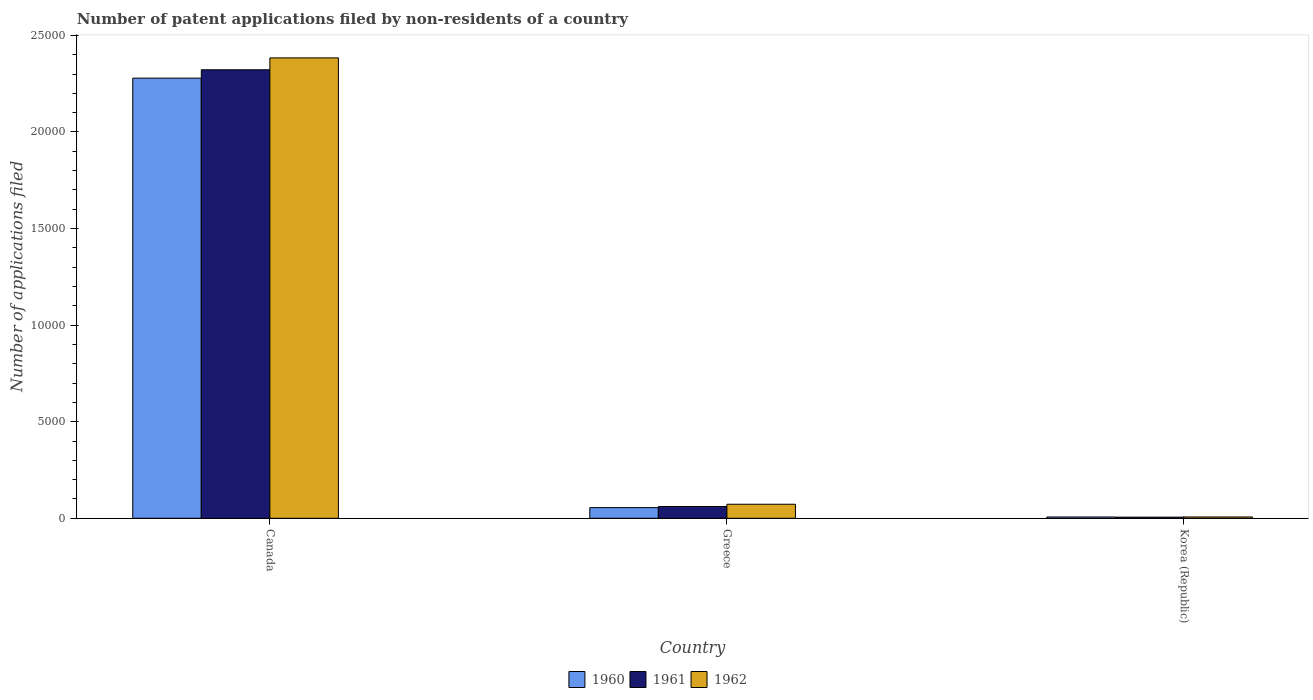How many different coloured bars are there?
Your response must be concise. 3. In how many cases, is the number of bars for a given country not equal to the number of legend labels?
Your answer should be very brief. 0. What is the number of applications filed in 1962 in Korea (Republic)?
Ensure brevity in your answer.  68. Across all countries, what is the maximum number of applications filed in 1960?
Offer a very short reply. 2.28e+04. In which country was the number of applications filed in 1960 minimum?
Your response must be concise. Korea (Republic). What is the total number of applications filed in 1960 in the graph?
Keep it short and to the point. 2.34e+04. What is the difference between the number of applications filed in 1961 in Canada and that in Greece?
Give a very brief answer. 2.26e+04. What is the difference between the number of applications filed in 1962 in Greece and the number of applications filed in 1961 in Canada?
Provide a short and direct response. -2.25e+04. What is the average number of applications filed in 1960 per country?
Give a very brief answer. 7801. What is the difference between the number of applications filed of/in 1962 and number of applications filed of/in 1961 in Greece?
Offer a terse response. 117. In how many countries, is the number of applications filed in 1960 greater than 16000?
Provide a short and direct response. 1. What is the ratio of the number of applications filed in 1960 in Canada to that in Greece?
Ensure brevity in your answer.  41.35. Is the number of applications filed in 1962 in Canada less than that in Greece?
Keep it short and to the point. No. What is the difference between the highest and the second highest number of applications filed in 1960?
Keep it short and to the point. 2.27e+04. What is the difference between the highest and the lowest number of applications filed in 1960?
Provide a succinct answer. 2.27e+04. In how many countries, is the number of applications filed in 1961 greater than the average number of applications filed in 1961 taken over all countries?
Keep it short and to the point. 1. What does the 2nd bar from the left in Canada represents?
Your response must be concise. 1961. Is it the case that in every country, the sum of the number of applications filed in 1962 and number of applications filed in 1960 is greater than the number of applications filed in 1961?
Provide a succinct answer. Yes. How many bars are there?
Provide a succinct answer. 9. Are all the bars in the graph horizontal?
Provide a short and direct response. No. How many countries are there in the graph?
Offer a very short reply. 3. What is the difference between two consecutive major ticks on the Y-axis?
Your answer should be very brief. 5000. Are the values on the major ticks of Y-axis written in scientific E-notation?
Your answer should be compact. No. Does the graph contain any zero values?
Provide a short and direct response. No. Where does the legend appear in the graph?
Your response must be concise. Bottom center. What is the title of the graph?
Provide a short and direct response. Number of patent applications filed by non-residents of a country. What is the label or title of the Y-axis?
Your response must be concise. Number of applications filed. What is the Number of applications filed of 1960 in Canada?
Provide a short and direct response. 2.28e+04. What is the Number of applications filed of 1961 in Canada?
Offer a very short reply. 2.32e+04. What is the Number of applications filed in 1962 in Canada?
Your answer should be compact. 2.38e+04. What is the Number of applications filed in 1960 in Greece?
Keep it short and to the point. 551. What is the Number of applications filed of 1961 in Greece?
Offer a very short reply. 609. What is the Number of applications filed in 1962 in Greece?
Your answer should be very brief. 726. What is the Number of applications filed of 1962 in Korea (Republic)?
Provide a short and direct response. 68. Across all countries, what is the maximum Number of applications filed in 1960?
Offer a terse response. 2.28e+04. Across all countries, what is the maximum Number of applications filed in 1961?
Give a very brief answer. 2.32e+04. Across all countries, what is the maximum Number of applications filed in 1962?
Provide a succinct answer. 2.38e+04. Across all countries, what is the minimum Number of applications filed in 1960?
Make the answer very short. 66. Across all countries, what is the minimum Number of applications filed in 1962?
Keep it short and to the point. 68. What is the total Number of applications filed in 1960 in the graph?
Provide a succinct answer. 2.34e+04. What is the total Number of applications filed of 1961 in the graph?
Give a very brief answer. 2.39e+04. What is the total Number of applications filed in 1962 in the graph?
Provide a succinct answer. 2.46e+04. What is the difference between the Number of applications filed in 1960 in Canada and that in Greece?
Make the answer very short. 2.22e+04. What is the difference between the Number of applications filed in 1961 in Canada and that in Greece?
Ensure brevity in your answer.  2.26e+04. What is the difference between the Number of applications filed in 1962 in Canada and that in Greece?
Provide a succinct answer. 2.31e+04. What is the difference between the Number of applications filed of 1960 in Canada and that in Korea (Republic)?
Provide a short and direct response. 2.27e+04. What is the difference between the Number of applications filed in 1961 in Canada and that in Korea (Republic)?
Provide a short and direct response. 2.32e+04. What is the difference between the Number of applications filed in 1962 in Canada and that in Korea (Republic)?
Make the answer very short. 2.38e+04. What is the difference between the Number of applications filed of 1960 in Greece and that in Korea (Republic)?
Make the answer very short. 485. What is the difference between the Number of applications filed of 1961 in Greece and that in Korea (Republic)?
Provide a succinct answer. 551. What is the difference between the Number of applications filed of 1962 in Greece and that in Korea (Republic)?
Keep it short and to the point. 658. What is the difference between the Number of applications filed of 1960 in Canada and the Number of applications filed of 1961 in Greece?
Your answer should be very brief. 2.22e+04. What is the difference between the Number of applications filed of 1960 in Canada and the Number of applications filed of 1962 in Greece?
Your response must be concise. 2.21e+04. What is the difference between the Number of applications filed in 1961 in Canada and the Number of applications filed in 1962 in Greece?
Ensure brevity in your answer.  2.25e+04. What is the difference between the Number of applications filed of 1960 in Canada and the Number of applications filed of 1961 in Korea (Republic)?
Ensure brevity in your answer.  2.27e+04. What is the difference between the Number of applications filed in 1960 in Canada and the Number of applications filed in 1962 in Korea (Republic)?
Make the answer very short. 2.27e+04. What is the difference between the Number of applications filed in 1961 in Canada and the Number of applications filed in 1962 in Korea (Republic)?
Offer a very short reply. 2.32e+04. What is the difference between the Number of applications filed in 1960 in Greece and the Number of applications filed in 1961 in Korea (Republic)?
Your answer should be compact. 493. What is the difference between the Number of applications filed of 1960 in Greece and the Number of applications filed of 1962 in Korea (Republic)?
Ensure brevity in your answer.  483. What is the difference between the Number of applications filed of 1961 in Greece and the Number of applications filed of 1962 in Korea (Republic)?
Your answer should be very brief. 541. What is the average Number of applications filed in 1960 per country?
Offer a very short reply. 7801. What is the average Number of applications filed of 1961 per country?
Make the answer very short. 7962. What is the average Number of applications filed of 1962 per country?
Ensure brevity in your answer.  8209.33. What is the difference between the Number of applications filed in 1960 and Number of applications filed in 1961 in Canada?
Keep it short and to the point. -433. What is the difference between the Number of applications filed of 1960 and Number of applications filed of 1962 in Canada?
Give a very brief answer. -1048. What is the difference between the Number of applications filed of 1961 and Number of applications filed of 1962 in Canada?
Your answer should be very brief. -615. What is the difference between the Number of applications filed in 1960 and Number of applications filed in 1961 in Greece?
Provide a succinct answer. -58. What is the difference between the Number of applications filed of 1960 and Number of applications filed of 1962 in Greece?
Ensure brevity in your answer.  -175. What is the difference between the Number of applications filed of 1961 and Number of applications filed of 1962 in Greece?
Your answer should be compact. -117. What is the difference between the Number of applications filed of 1960 and Number of applications filed of 1962 in Korea (Republic)?
Provide a short and direct response. -2. What is the difference between the Number of applications filed in 1961 and Number of applications filed in 1962 in Korea (Republic)?
Your response must be concise. -10. What is the ratio of the Number of applications filed in 1960 in Canada to that in Greece?
Offer a terse response. 41.35. What is the ratio of the Number of applications filed in 1961 in Canada to that in Greece?
Your answer should be very brief. 38.13. What is the ratio of the Number of applications filed in 1962 in Canada to that in Greece?
Offer a very short reply. 32.83. What is the ratio of the Number of applications filed of 1960 in Canada to that in Korea (Republic)?
Make the answer very short. 345.24. What is the ratio of the Number of applications filed of 1961 in Canada to that in Korea (Republic)?
Your answer should be very brief. 400.33. What is the ratio of the Number of applications filed of 1962 in Canada to that in Korea (Republic)?
Provide a short and direct response. 350.5. What is the ratio of the Number of applications filed in 1960 in Greece to that in Korea (Republic)?
Provide a short and direct response. 8.35. What is the ratio of the Number of applications filed of 1961 in Greece to that in Korea (Republic)?
Your answer should be compact. 10.5. What is the ratio of the Number of applications filed of 1962 in Greece to that in Korea (Republic)?
Give a very brief answer. 10.68. What is the difference between the highest and the second highest Number of applications filed of 1960?
Provide a succinct answer. 2.22e+04. What is the difference between the highest and the second highest Number of applications filed in 1961?
Provide a succinct answer. 2.26e+04. What is the difference between the highest and the second highest Number of applications filed of 1962?
Offer a very short reply. 2.31e+04. What is the difference between the highest and the lowest Number of applications filed in 1960?
Your answer should be compact. 2.27e+04. What is the difference between the highest and the lowest Number of applications filed in 1961?
Provide a succinct answer. 2.32e+04. What is the difference between the highest and the lowest Number of applications filed in 1962?
Keep it short and to the point. 2.38e+04. 